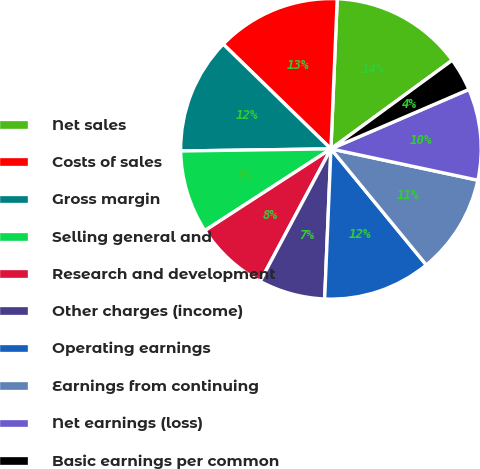Convert chart to OTSL. <chart><loc_0><loc_0><loc_500><loc_500><pie_chart><fcel>Net sales<fcel>Costs of sales<fcel>Gross margin<fcel>Selling general and<fcel>Research and development<fcel>Other charges (income)<fcel>Operating earnings<fcel>Earnings from continuing<fcel>Net earnings (loss)<fcel>Basic earnings per common<nl><fcel>14.29%<fcel>13.39%<fcel>12.5%<fcel>8.93%<fcel>8.04%<fcel>7.14%<fcel>11.61%<fcel>10.71%<fcel>9.82%<fcel>3.57%<nl></chart> 